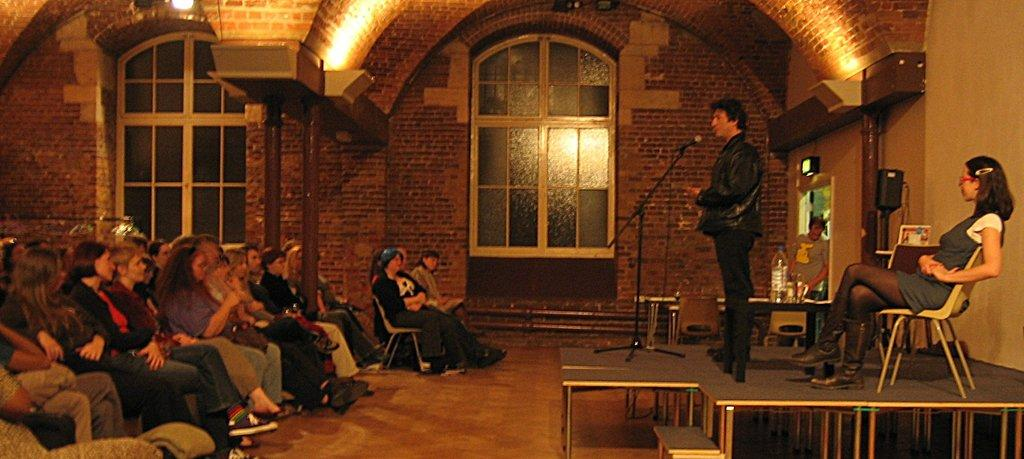What are the people in the image doing? The people in the image are sitting on chairs. Are there any other people in the image besides those sitting? Yes, two persons are standing in the image. What object is present that is typically used for amplifying sound? There is a microphone with a stand in the image. What can be seen on the floor in the image? The floor is visible in the image. What is visible in the background of the image? There is a wall, a glass window, and lights in the background. How many spiders can be seen crawling on the microphone stand in the image? There are no spiders present in the image, and therefore none can be seen crawling on the microphone stand. What type of material is being rubbed on the wall in the image? There is no indication of any material being rubbed on the wall in the image. 